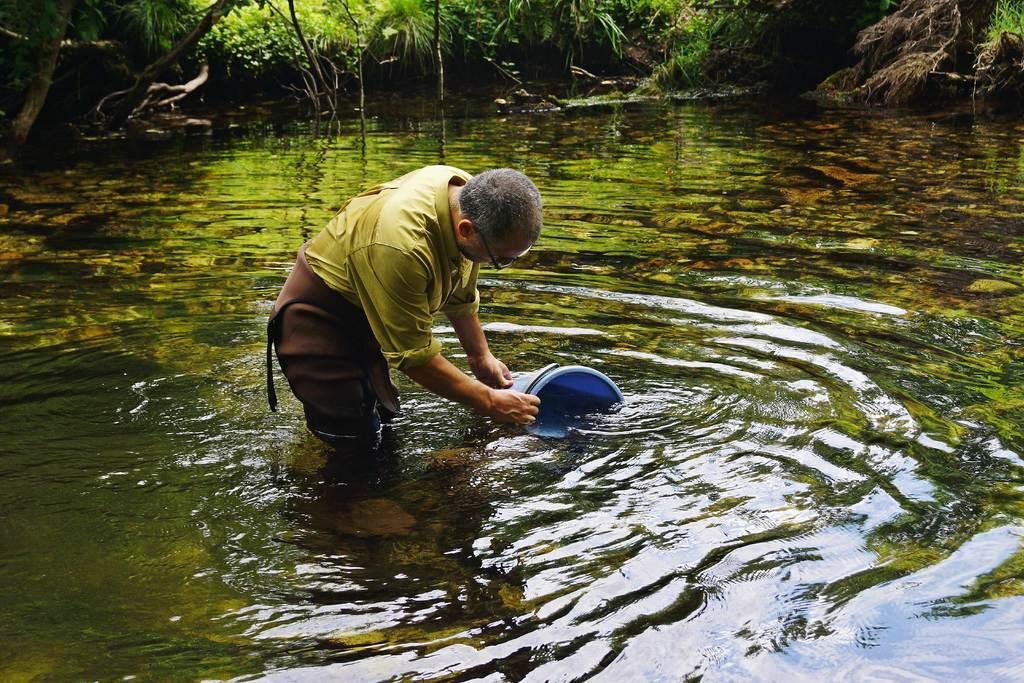Can you describe this image briefly? In the picture I can see a man in the water and he is holding a blue color bucket. I can see the trees on the side of the lake at the top of the picture. 